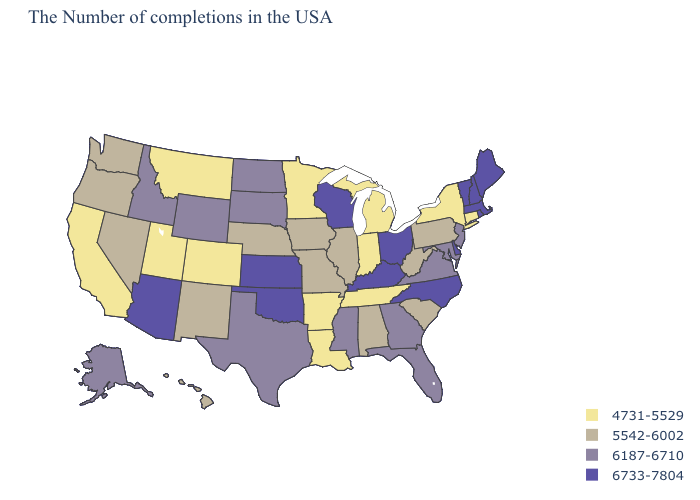What is the value of Alaska?
Answer briefly. 6187-6710. What is the highest value in states that border Vermont?
Answer briefly. 6733-7804. What is the lowest value in the USA?
Write a very short answer. 4731-5529. Which states have the highest value in the USA?
Write a very short answer. Maine, Massachusetts, Rhode Island, New Hampshire, Vermont, Delaware, North Carolina, Ohio, Kentucky, Wisconsin, Kansas, Oklahoma, Arizona. Among the states that border Kentucky , does Indiana have the lowest value?
Short answer required. Yes. Does Minnesota have the lowest value in the MidWest?
Write a very short answer. Yes. Among the states that border Illinois , which have the lowest value?
Quick response, please. Indiana. Name the states that have a value in the range 5542-6002?
Concise answer only. Pennsylvania, South Carolina, West Virginia, Alabama, Illinois, Missouri, Iowa, Nebraska, New Mexico, Nevada, Washington, Oregon, Hawaii. Name the states that have a value in the range 6733-7804?
Be succinct. Maine, Massachusetts, Rhode Island, New Hampshire, Vermont, Delaware, North Carolina, Ohio, Kentucky, Wisconsin, Kansas, Oklahoma, Arizona. What is the value of Florida?
Concise answer only. 6187-6710. Name the states that have a value in the range 4731-5529?
Write a very short answer. Connecticut, New York, Michigan, Indiana, Tennessee, Louisiana, Arkansas, Minnesota, Colorado, Utah, Montana, California. Name the states that have a value in the range 5542-6002?
Write a very short answer. Pennsylvania, South Carolina, West Virginia, Alabama, Illinois, Missouri, Iowa, Nebraska, New Mexico, Nevada, Washington, Oregon, Hawaii. What is the value of Delaware?
Short answer required. 6733-7804. Does North Dakota have the lowest value in the MidWest?
Answer briefly. No. What is the lowest value in states that border Michigan?
Concise answer only. 4731-5529. 